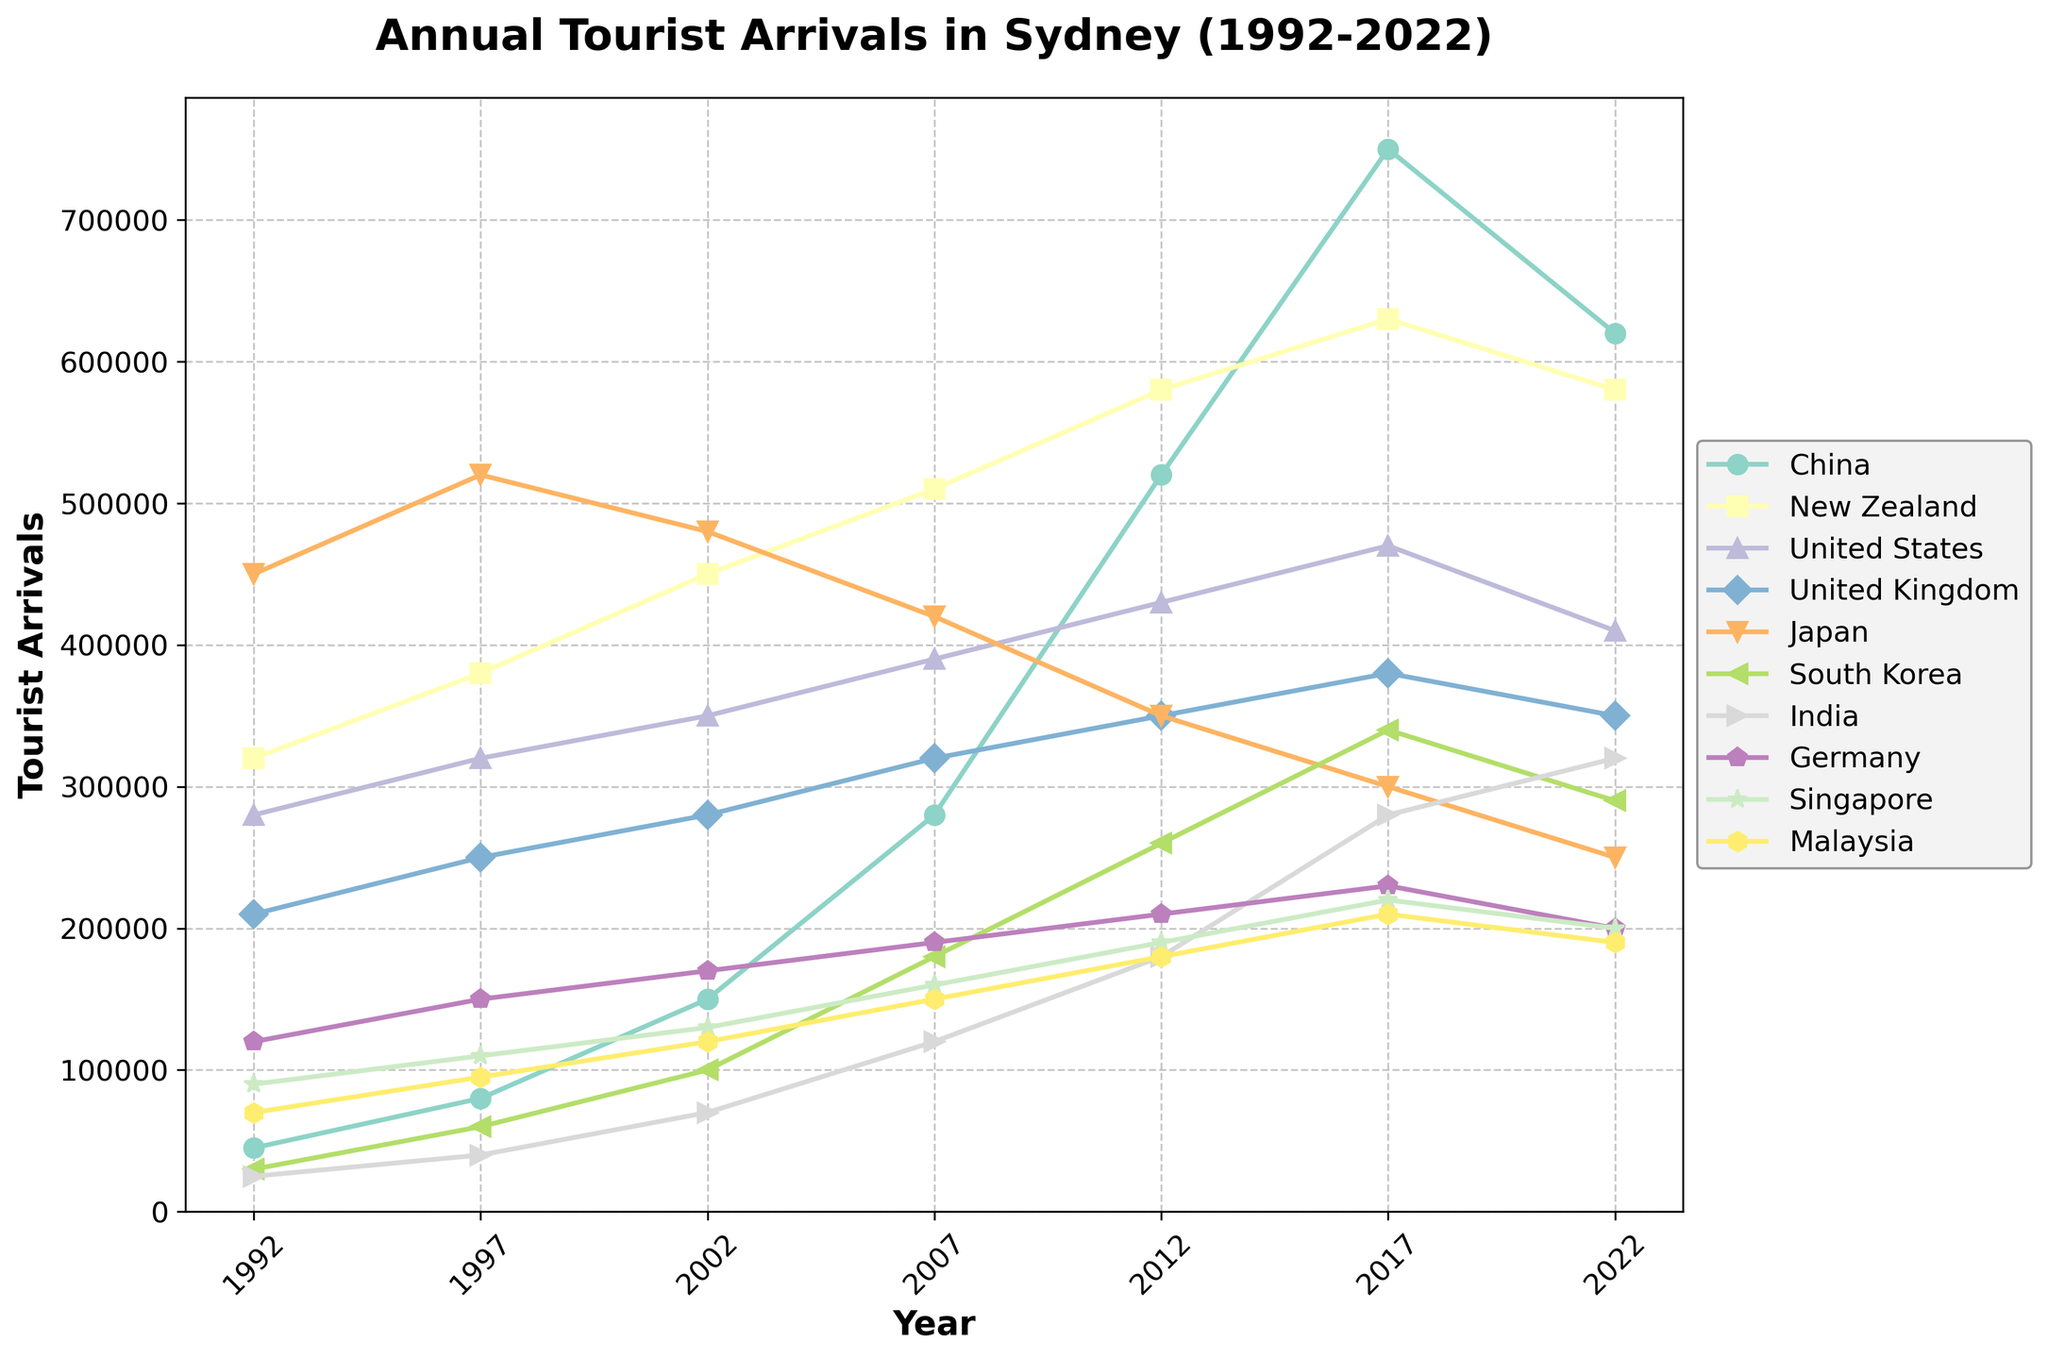Which country had the most tourist arrivals in Sydney in 1992? Look at the lines for each country in the figure for the year 1992. The highest value is for Japan.
Answer: Japan Which country saw the largest increase in tourist arrivals from 1992 to 2017? Compare the values for each country in 1992 and 2017, and find the country with the maximum difference. China had 45000 in 1992 and 750000 in 2017, which is an increase of 705000.
Answer: China Compare the tourist arrivals between the United States and the United Kingdom in 2022. Which country had more tourists? Look at the data points for the United States and the United Kingdom in 2022. The United States had 410000, while the United Kingdom had 350000.
Answer: United States Which country had the least tourist arrivals in 2007? Check all lines for the year 2007 and identify the lowest value. Malaysia had 150000 tourist arrivals, the least among all countries.
Answer: Malaysia Did South Korea ever have more tourist arrivals than United States? If yes, when? Examine the lines for South Korea and the United States across all years to identify if South Korea surpasses the United States at any point. In 2017, South Korea had 340000 and the United States had 470000, which means South Korea never surpassed the United States.
Answer: No What was the average number of tourist arrivals from New Zealand over the years provided? Sum the values of tourist arrivals from New Zealand (320000, 380000, 450000, 510000, 580000, 630000, 580000) and divide by the number of years (7). (320000 + 380000 + 450000 + 510000 + 580000 + 630000 + 580000) / 7 = 493571.4
Answer: 493571.4 How did the tourist arrivals from Germany change between 1992 and 2022? Look at the data points for Germany in 1992 and 2022 to find the change. Germany had 120000 in 1992 and 200000 in 2022, which is an increase of 80000.
Answer: Increased by 80000 Which two countries had similar tourist arrival numbers in 2022? Look for countries with the closest data points in 2022. India and Germany both had 200000 tourist arrivals.
Answer: India and Germany How many countries had over 500000 tourist arrivals in 2017? Check all values for each country in 2017 and count those over 500000. China (750000), New Zealand (630000) had over 500000 tourist arrivals.
Answer: 2 Overall, did tourist arrivals increase or decrease for Japan from 1992 to 2022? Check the values for Japan from 1992 (450000) to 2022 (250000). Since 250000 is less than 450000, there was a decrease.
Answer: Decrease 